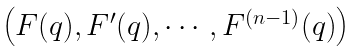<formula> <loc_0><loc_0><loc_500><loc_500>\begin{pmatrix} F ( q ) , F ^ { \prime } ( q ) , \cdots , F ^ { ( n - 1 ) } ( q ) \end{pmatrix}</formula> 